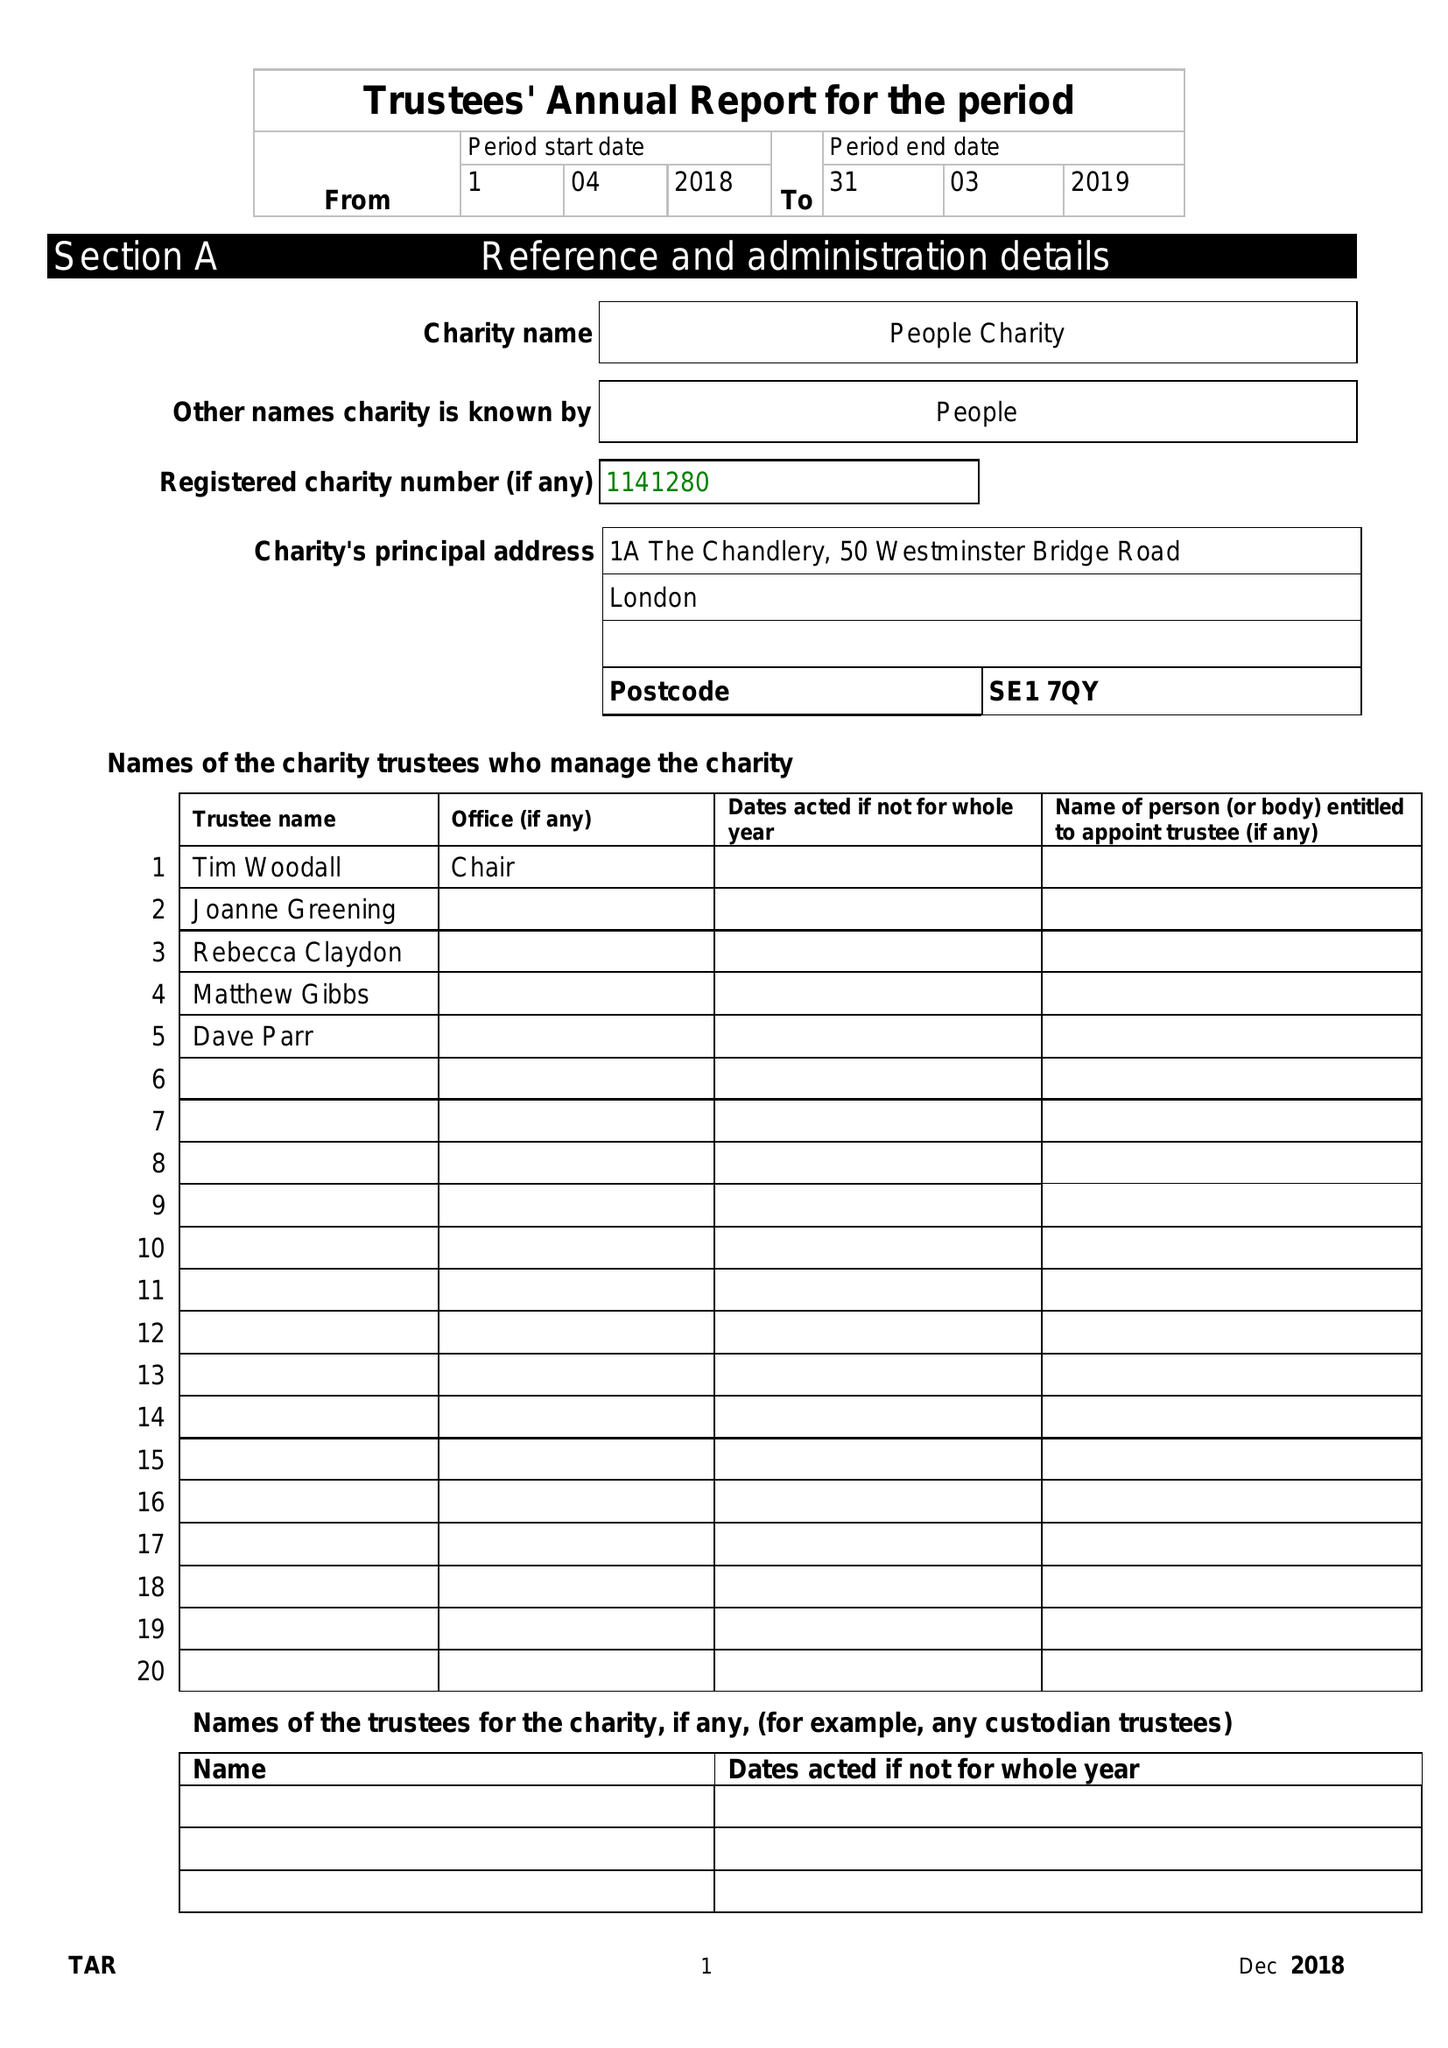What is the value for the address__postcode?
Answer the question using a single word or phrase. SE1 7QY 